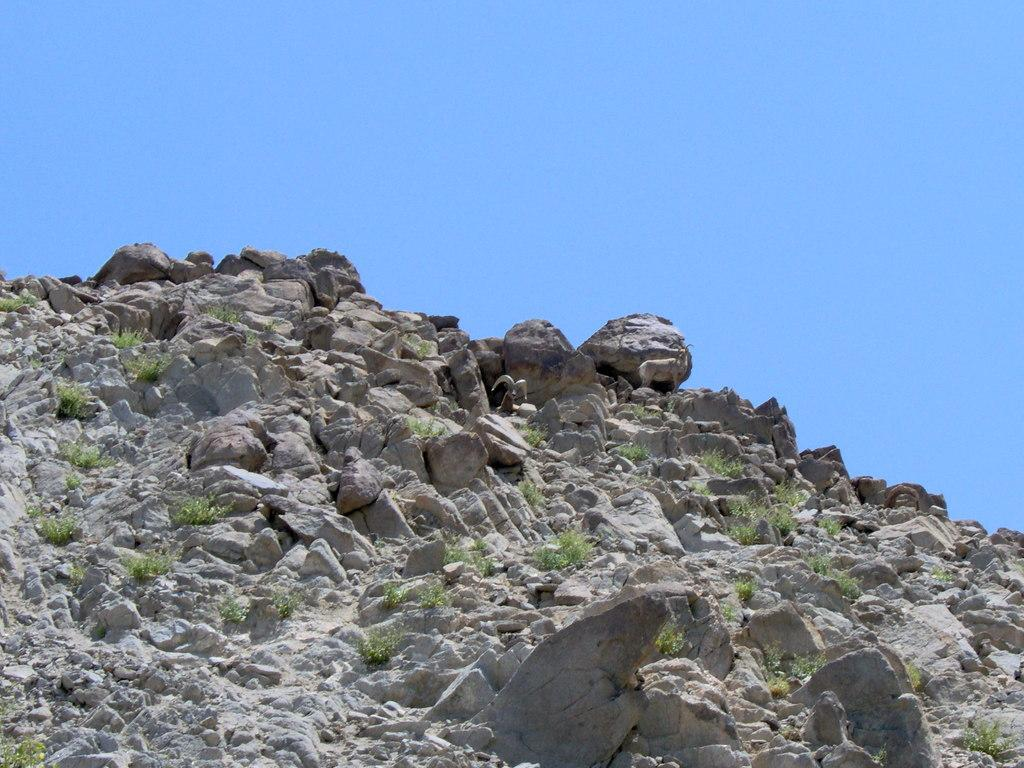What geographical feature is present in the image? There is a hill in the image. What can be found on the hill? There are plants and rocks on the hill. What is visible in the background of the image? The sky is visible in the background of the image. What type of pancake is being served on the hill in the image? There is no pancake present in the image; it features a hill with plants and rocks. Can you see any faces on the hill in the image? There are no faces visible on the hill in the image. 